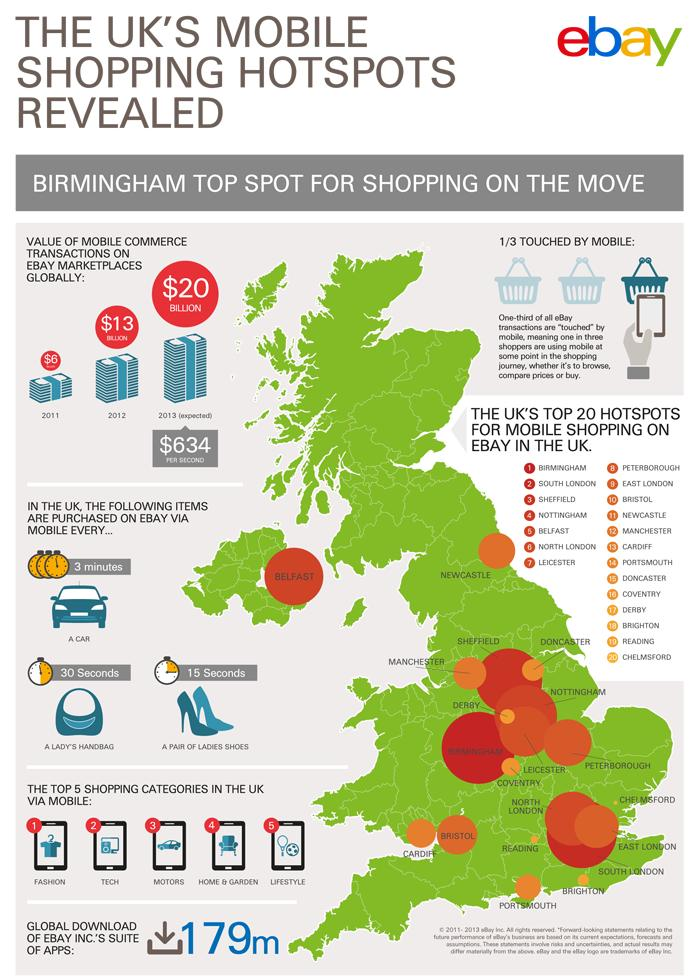Mention a couple of crucial points in this snapshot. Tech products are the second most frequently purchased items through mobile devices in the United Kingdom. According to data, a significant majority of eBay users are not using mobile devices to access the platform. On average, every 15 seconds in the UK, a pair of ladies shoes is sold through eBay. E Bay Mobile transactions for a second are worth approximately $634. Lifestyle products are the fifth most frequently purchased through mobile devices in the United Kingdom. 